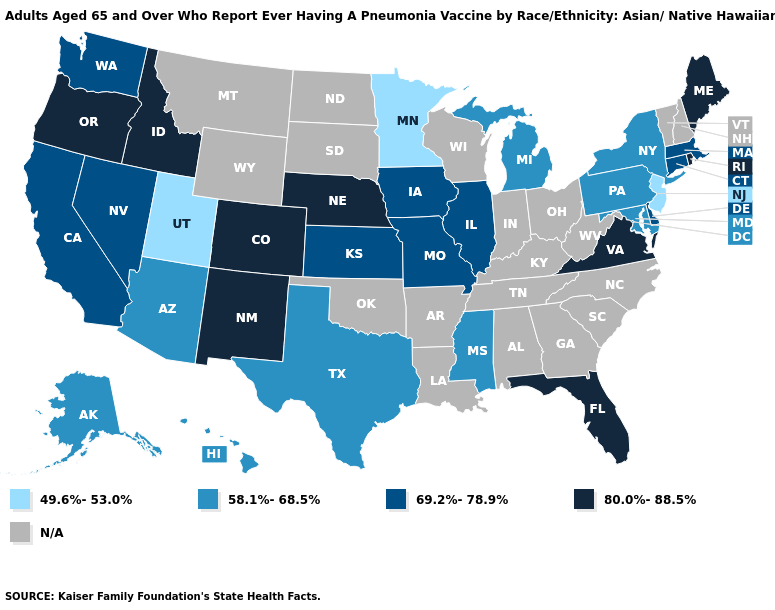What is the value of Alaska?
Give a very brief answer. 58.1%-68.5%. What is the value of Oregon?
Write a very short answer. 80.0%-88.5%. Name the states that have a value in the range 80.0%-88.5%?
Short answer required. Colorado, Florida, Idaho, Maine, Nebraska, New Mexico, Oregon, Rhode Island, Virginia. What is the value of New Mexico?
Quick response, please. 80.0%-88.5%. Name the states that have a value in the range 58.1%-68.5%?
Answer briefly. Alaska, Arizona, Hawaii, Maryland, Michigan, Mississippi, New York, Pennsylvania, Texas. Name the states that have a value in the range 80.0%-88.5%?
Write a very short answer. Colorado, Florida, Idaho, Maine, Nebraska, New Mexico, Oregon, Rhode Island, Virginia. Does New Jersey have the lowest value in the Northeast?
Concise answer only. Yes. What is the value of Wyoming?
Give a very brief answer. N/A. What is the value of New Hampshire?
Keep it brief. N/A. Name the states that have a value in the range 69.2%-78.9%?
Give a very brief answer. California, Connecticut, Delaware, Illinois, Iowa, Kansas, Massachusetts, Missouri, Nevada, Washington. How many symbols are there in the legend?
Be succinct. 5. What is the lowest value in the USA?
Be succinct. 49.6%-53.0%. What is the value of South Dakota?
Answer briefly. N/A. Name the states that have a value in the range 49.6%-53.0%?
Quick response, please. Minnesota, New Jersey, Utah. What is the value of West Virginia?
Keep it brief. N/A. 